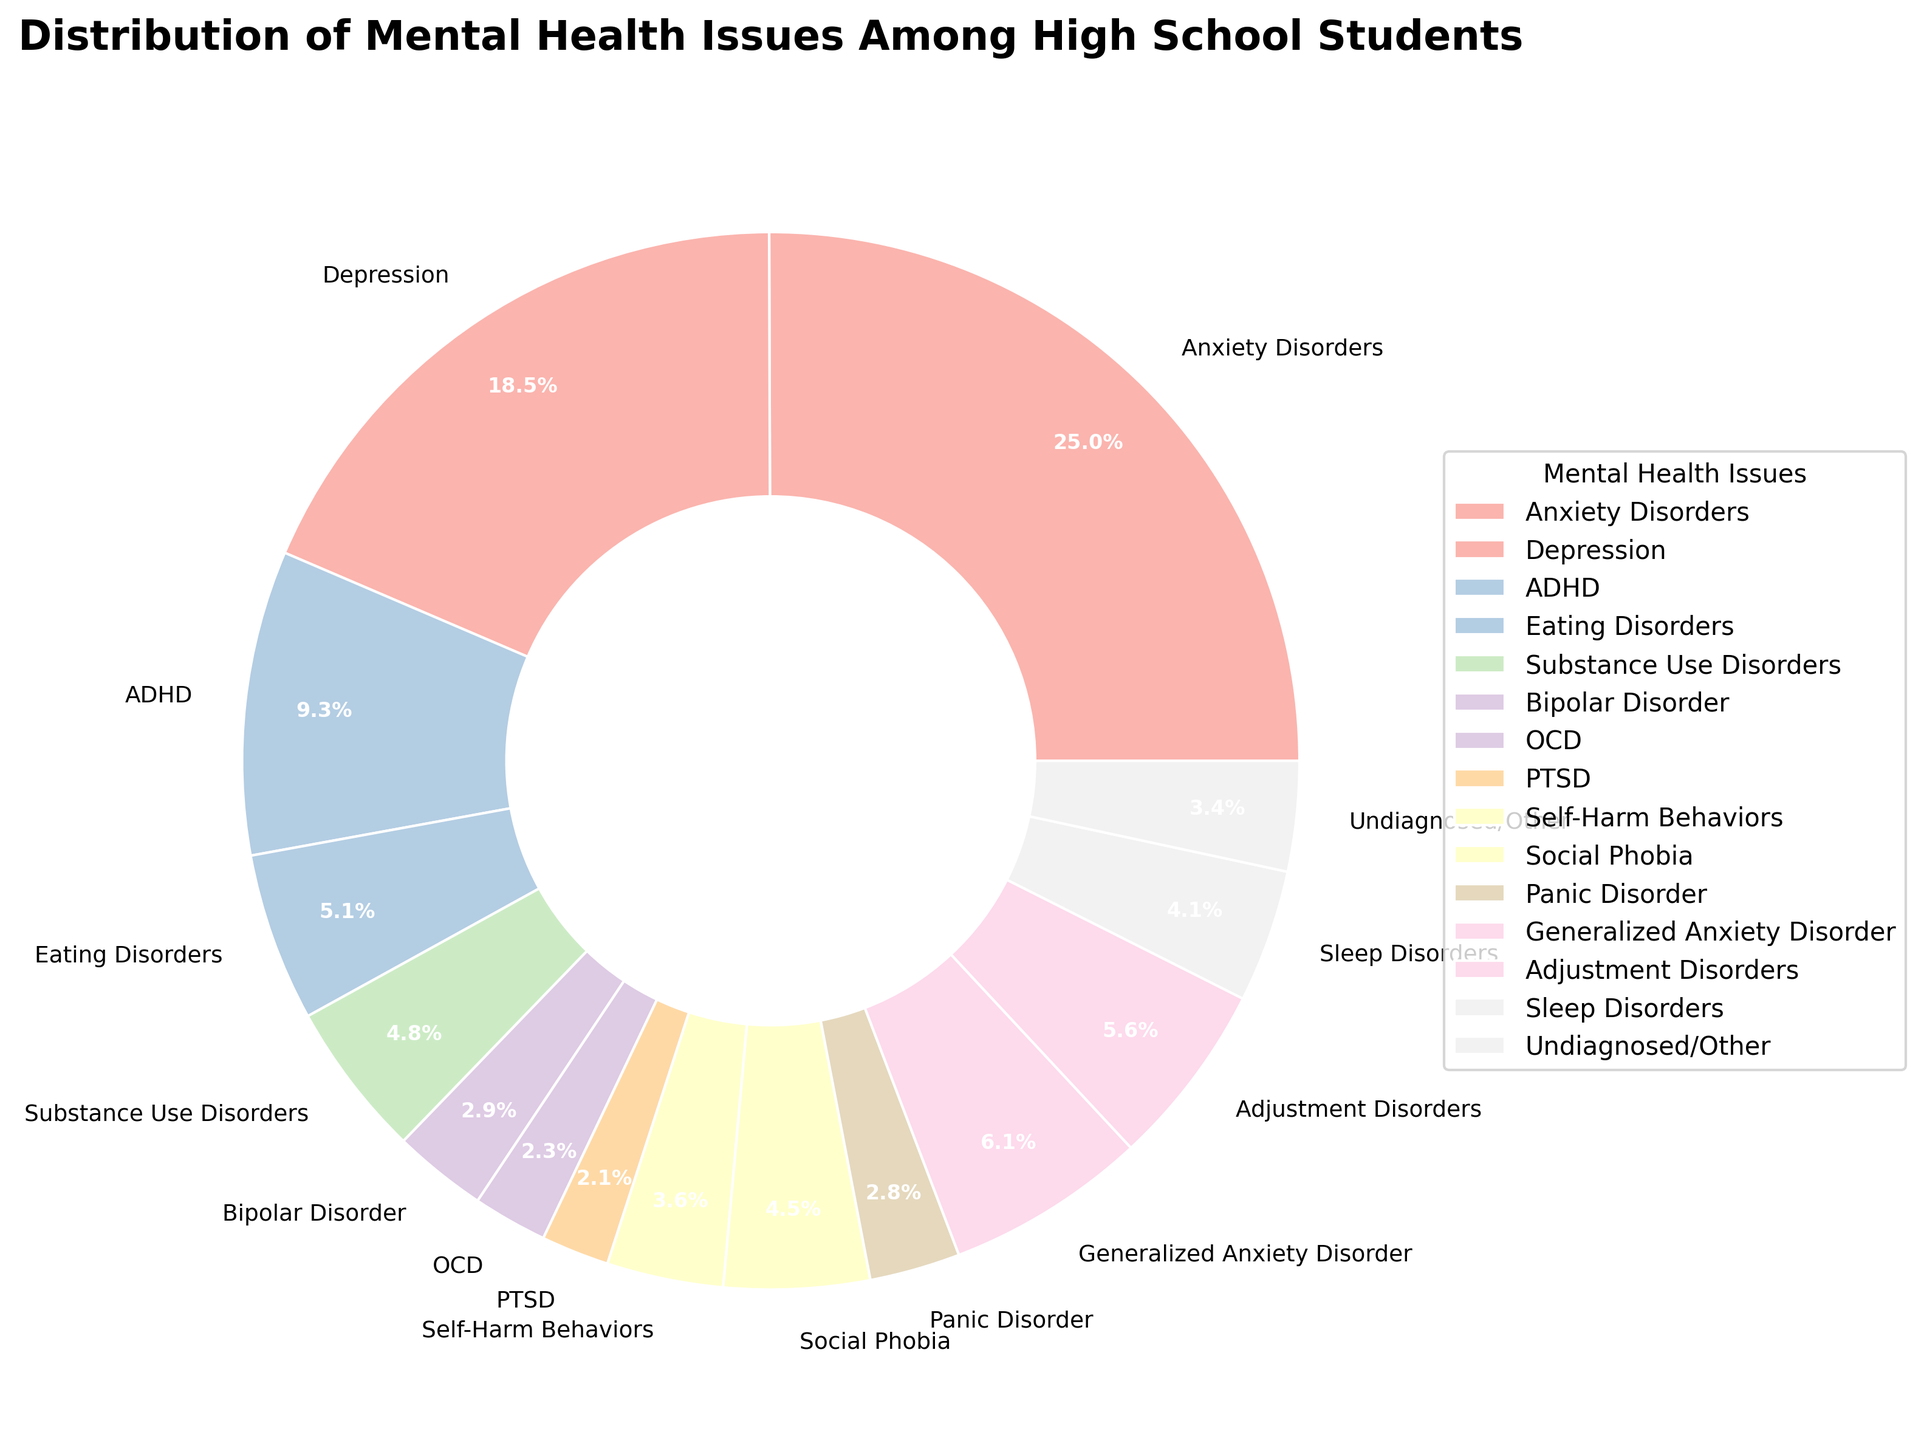What is the most common mental health issue among high school students according to the pie chart? The pie chart shows different mental health issues and their corresponding percentages. The largest wedge represents Anxiety Disorders, which has the highest percentage of 25.3%.
Answer: Anxiety Disorders What percentages of high school students face Depression compared to Anxiety Disorders? In the pie chart, Anxiety Disorders are at 25.3% while Depression is at 18.7%. To compare, 25.3% - 18.7% = 6.6% more students face Anxiety Disorders than Depression.
Answer: 6.6% Which mental health issue has a slightly lower percentage than ADHD? The pie chart shows ADHD at 9.4%. The mental health issue with a slightly lower percentage, next in line, is Generalized Anxiety Disorder at 6.2%.
Answer: Generalized Anxiety Disorder What is the total percentage for the combined categories of Depression, Self-Harm Behaviors, and OCD? From the pie chart, Depression is 18.7%, Self-Harm Behaviors is 3.6%, and OCD is 2.3%. Adding these percentages: 18.7% + 3.6% + 2.3% = 24.6%.
Answer: 24.6% Which mental health issues have percentages lower than Substance Use Disorders? The pie chart indicates Substance Use Disorders at 4.8%. The issues with lower percentages are Bipolar Disorder (2.9%), OCD (2.3%), PTSD (2.1%), Panic Disorder (2.8%), and Undiagnosed/Other (3.4%).
Answer: Bipolar Disorder, OCD, PTSD, Panic Disorder, Undiagnosed/Other Are there more high school students with Eating Disorders or Social Phobia? The pie chart shows Eating Disorders at 5.2% and Social Phobia at 4.5%. Comparing these values, 5.2% is greater than 4.5%, so more students have Eating Disorders.
Answer: Eating Disorders How does the percentage of Panic Disorder compare to Sleep Disorders? The pie chart shows Panic Disorder at 2.8% and Sleep Disorders at 4.1%. Since 4.1% is greater than 2.8%, a higher percentage of students have Sleep Disorders compared to Panic Disorder.
Answer: Sleep Disorders What is the percentage difference between Bipolar Disorder and Adjustment Disorders? The pie chart shows Bipolar Disorder at 2.9% and Adjustment Disorders at 5.7%. The difference is 5.7% - 2.9% = 2.8%.
Answer: 2.8% What is the combined percentage of all the issues listed under 5%? The percentages for issues under 5% are Substance Use Disorders (4.8%), Bipolar Disorder (2.9%), OCD (2.3%), PTSD (2.1%), Self-Harm Behaviors (3.6%), Social Phobia (4.5%), Panic Disorder (2.8%), Adjustment Disorders (5.7% not under 5%), Sleep Disorders (4.1%), Undiagnosed/Other (3.4%). Adding these: 4.8% + 2.9% + 2.3% + 2.1% + 3.6% + 4.5% + 2.8% + 4.1% + 3.4% = 30.5%.
Answer: 30.5% 